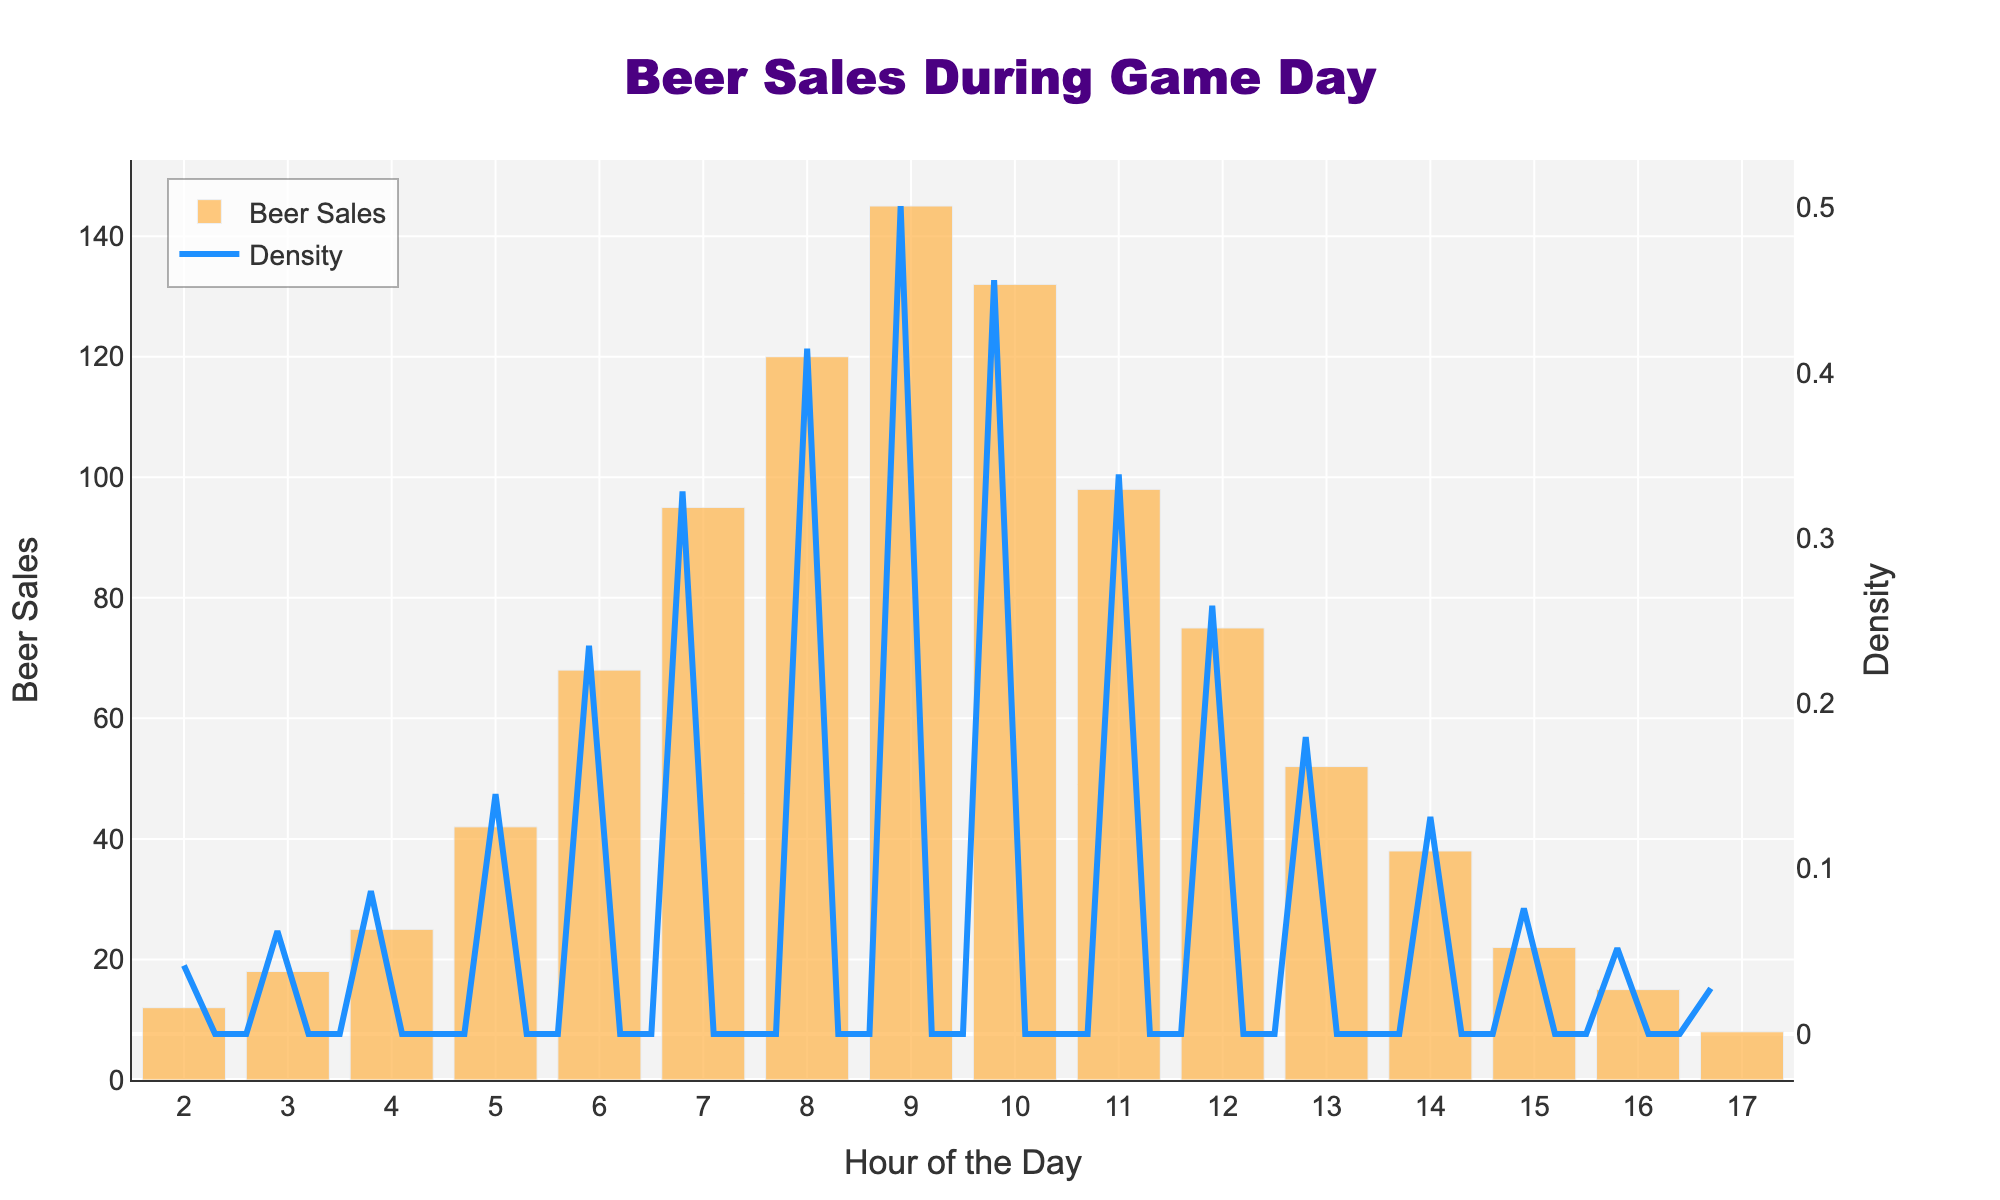What is the title of the figure? The title is displayed at the top of the figure, centered, reading "Beer Sales During Game Day."
Answer: Beer Sales During Game Day What does the X-axis represent? The label below the X-axis indicates it represents the "Hour of the Day."
Answer: Hour of the Day At what hour do the beer sales peak? By observing the bar heights, the highest bar is at hour 9.
Answer: 9 How does the density curve compare at hour 8 and hour 12? The KDE curve is higher at hour 8 than at hour 12, indicating a higher density of sales around hour 8.
Answer: Higher at hour 8 What color are the bars representing beer sales? The bars are colored in a shade of orange.
Answer: Orange What types of data are visualized on the two Y-axes? The primary Y-axis on the left shows "Beer Sales," while the secondary Y-axis on the right shows "Density."
Answer: Beer Sales and Density During which hours do beer sales drop below 20? Observing the figure, beer sales are below 20 during hours 2, 16, and 17.
Answer: 2, 16, and 17 What is the range of hours displayed on the X-axis? The X-axis displays hours from 2 to 17.
Answer: 2 to 17 When does the density curve show its highest peak, and what does this indicate? The highest peak of the density curve is around hour 9, indicating the densest occurrence of beer sales around that time.
Answer: Hour 9 What is the color of the density curve and its significance? The density curve is dark blue, representing the density of the beer sales distribution over the hours.
Answer: Dark blue 